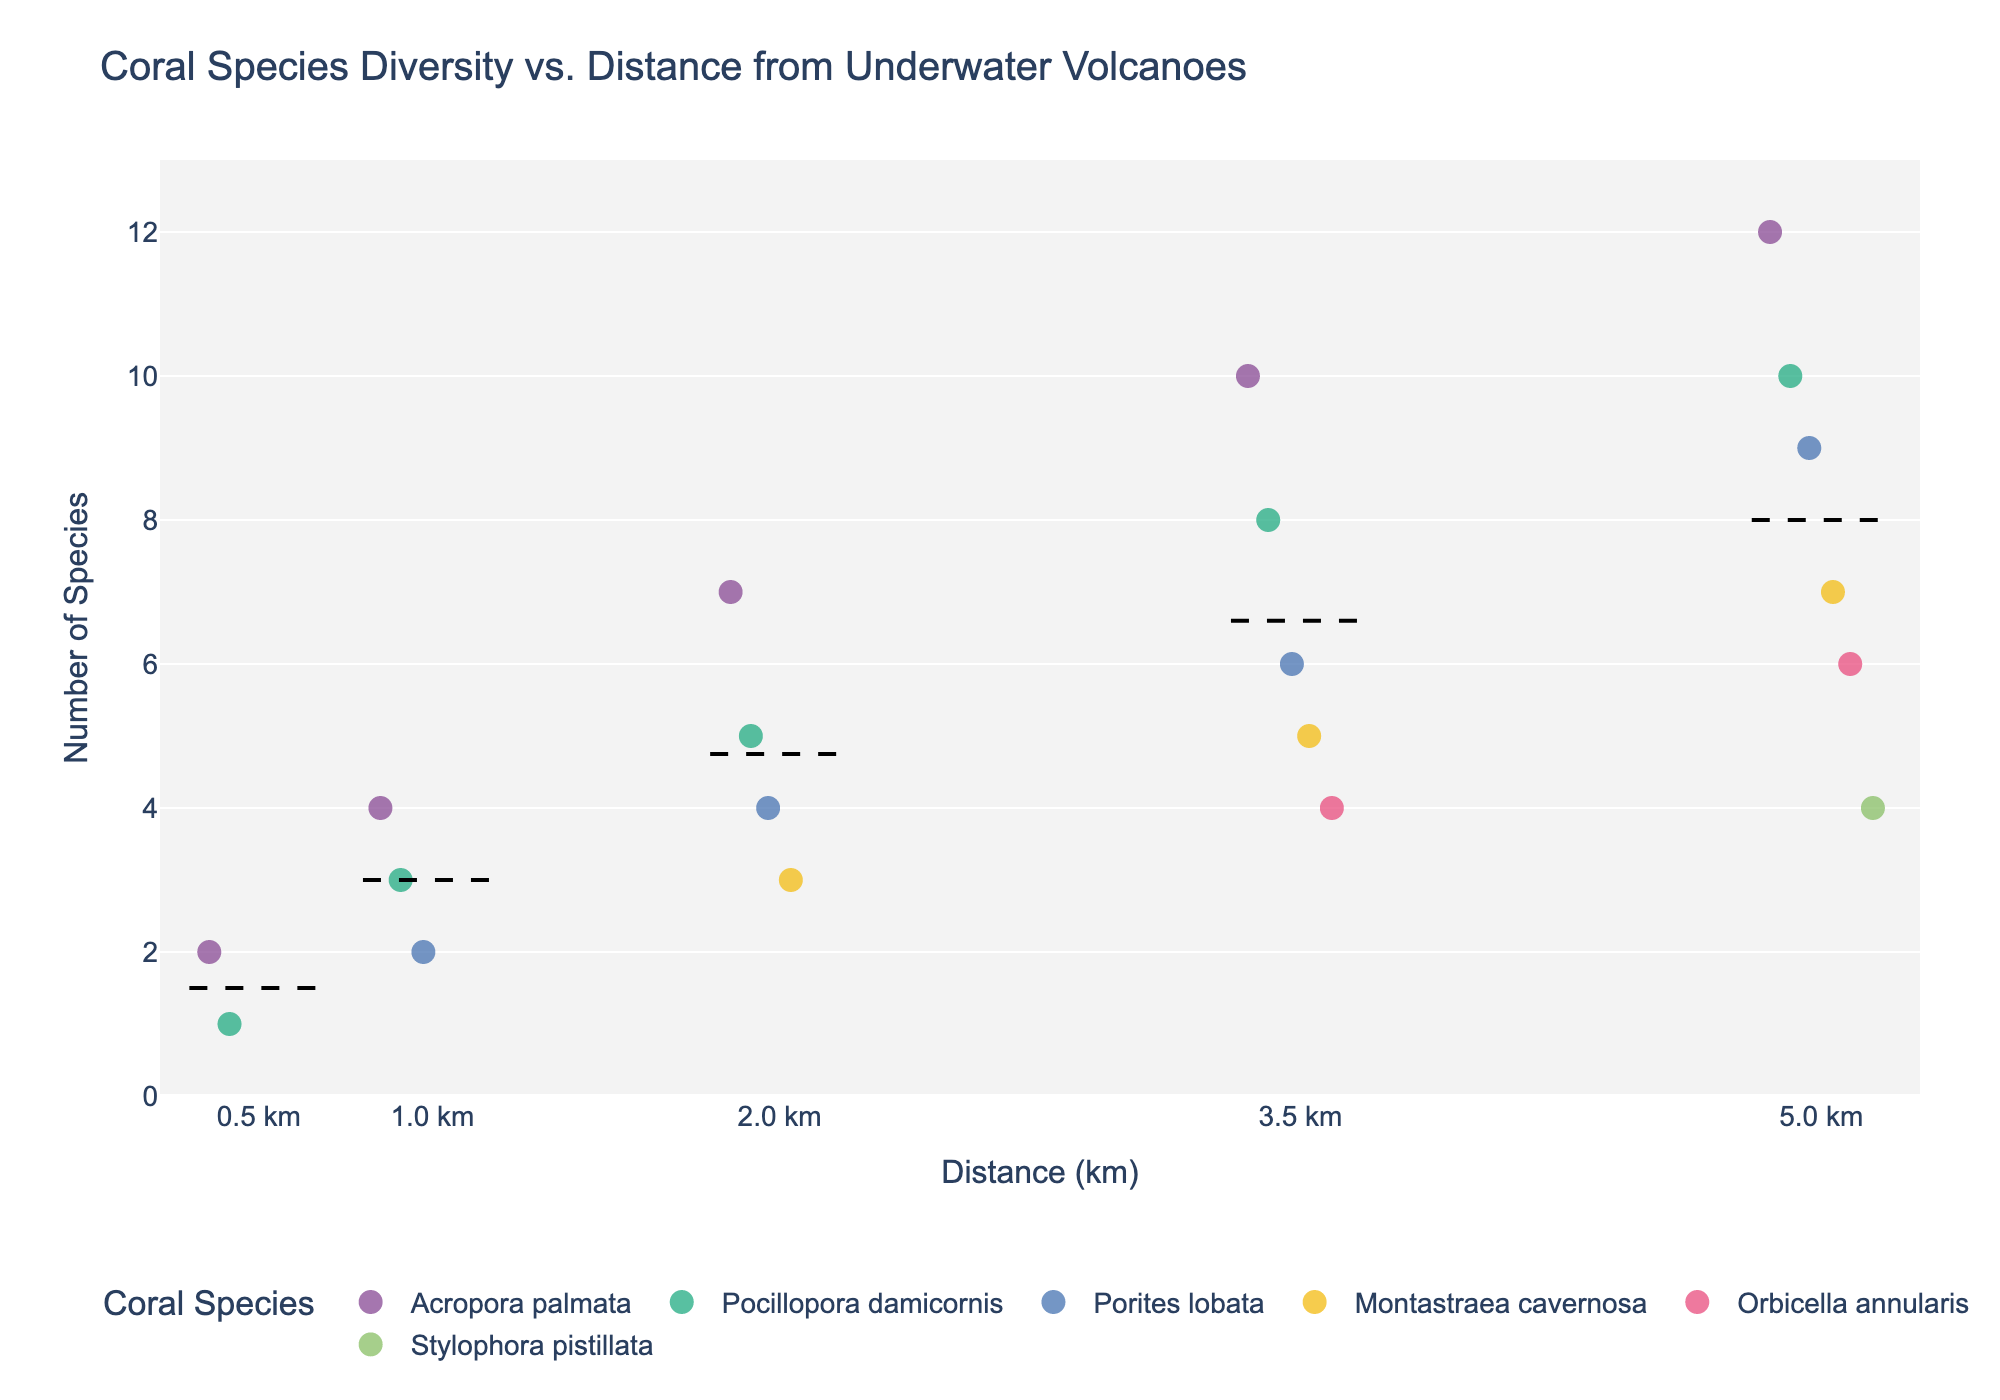What is the title of the figure? The title is located at the top of the figure, summarizing the relationship between coral species diversity and their distance from underwater volcanoes.
Answer: Coral Species Diversity vs. Distance from Underwater Volcanoes Which coral species is represented with the largest count at a distance of 3.5 km? Look at the data points at 3.5 km distance and find the species with the highest count.
Answer: Acropora palmata How many different coral species are shown at a distance of 5.0 km? Count the unique coral species names along the x-axis at the 5.0 km distance.
Answer: 5 Which distance shows the highest average species count? Look for the dashed lines that represent the mean species count for each distance and identify the highest one.
Answer: 5.0 km What is the mean species count at a distance of 1.0 km? Locate the dashed line at the 1.0 km distance and read the y-axis value where it intersects.
Answer: 3 Does Porites lobata have a higher species count at 2.0 km or at 5.0 km? Compare the Porites lobata data points at both 2.0 km and 5.0 km distances and identify the higher value.
Answer: 5.0 km Which coral species is observed at all distances shown in the figure? Check which coral species appear at every distance (0.5, 1.0, 2.0, 3.5, and 5.0 km).
Answer: Acropora palmata and Pocillopora damicornis What is the total species count for Montastraea cavernosa at all distances combined? Sum the species counts for Montastraea cavernosa at each distance.
Answer: 3 + 5 + 7 = 15 How does the species count of Orbicella annularis change as distance increases from 3.5 km to 5.0 km? Compare the species counts of Orbicella annularis at 3.5 km and 5.0 km and describe the change.
Answer: It increases from 4 to 6 What is the range of species counts observed for Stylophora pistillata? Identify the minimum and maximum species counts for Stylophora pistillata and calculate the difference between them.
Answer: 4 - 4 = 0 